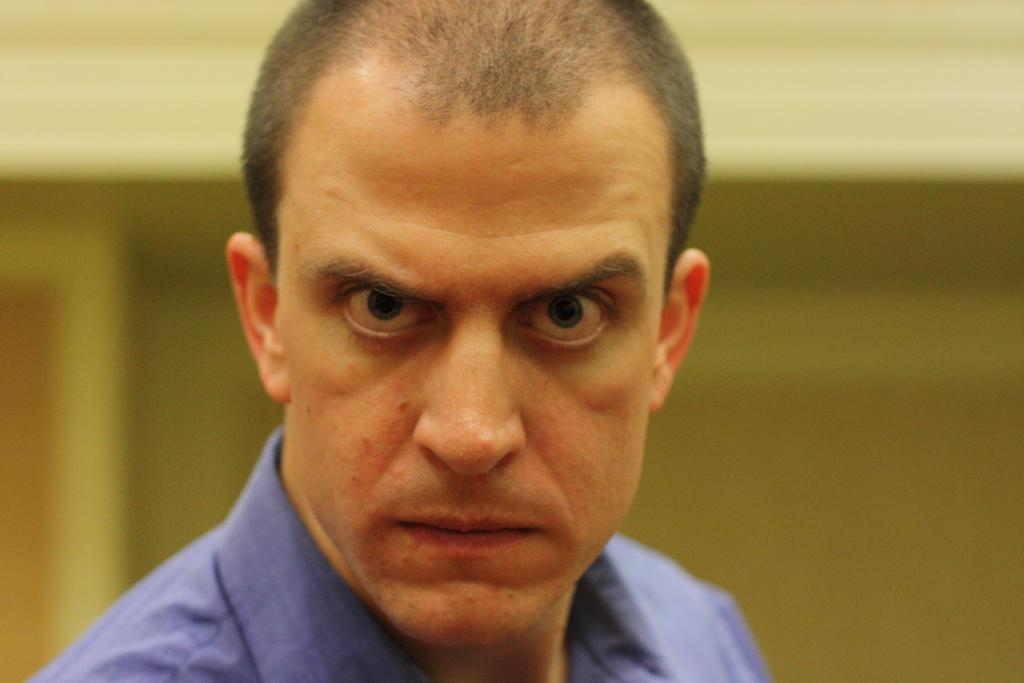Where was the image most likely taken? The image was likely clicked indoors. What can be seen in the foreground of the image? There is a person in the foreground of the image. What is the person wearing? The person is wearing a blue shirt. What is visible in the background of the image? There is a wall in the background of the image. What type of silk material can be seen draped over the person's shoulder in the image? There is no silk material visible in the image; the person is wearing a blue shirt. How much lead is present in the wall visible in the background of the image? The image does not provide information about the composition of the wall, so it is impossible to determine the amount of lead present. 